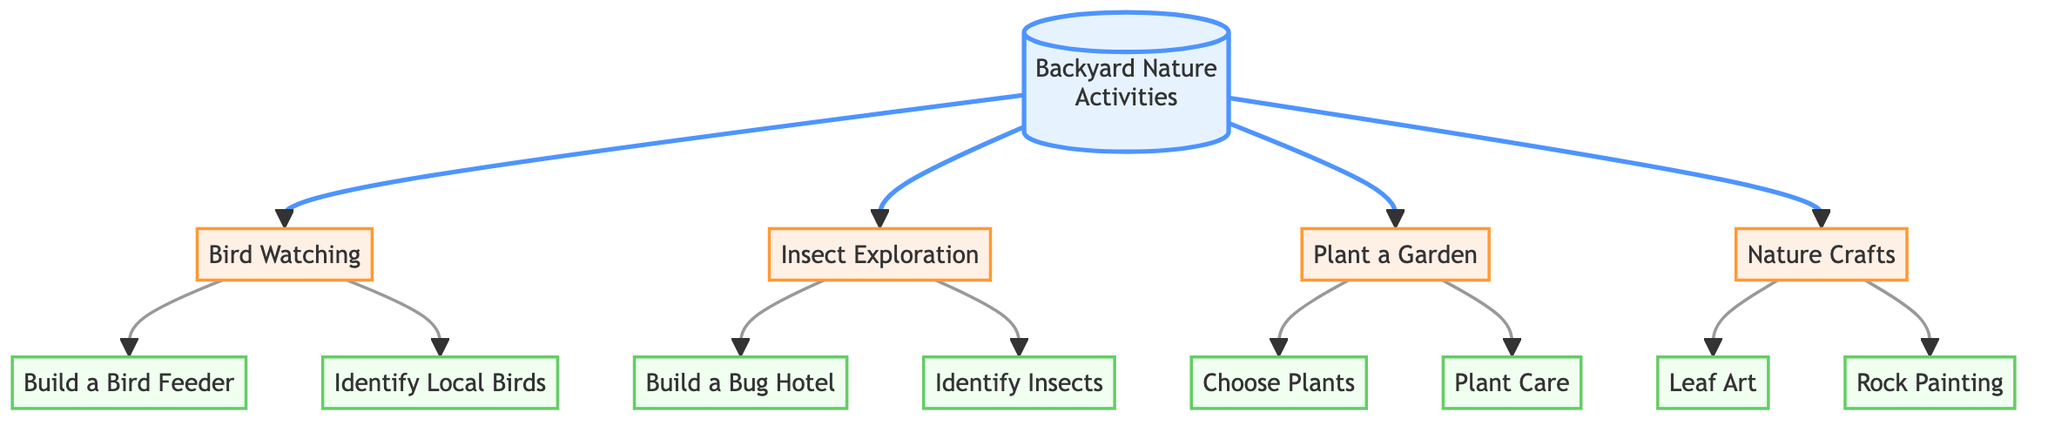What is the main topic of the diagram? The diagram starts with the node labeled "Backyard Nature Activities," indicating that this is the primary focus of the diagram.
Answer: Backyard Nature Activities How many main activities are listed in the diagram? The diagram shows three main activities branching from "Backyard Nature Activities": "Bird Watching," "Insect Exploration," and "Plant a Garden." Counting these gives us three activities.
Answer: 3 What is one subactivity under "Bird Watching"? One of the subactivities connected to "Bird Watching" is "Build a Bird Feeder," which directly links from the "Bird Watching" node.
Answer: Build a Bird Feeder Which main activity has the most subactivities associated with it? Examining the diagram, "Nature Crafts" has two subactivities: "Leaf Art" and "Rock Painting." In contrast, "Bird Watching" and "Insect Exploration" each have two subactivities, while "Plant a Garden" has two as well. However, they are equal, indicating that none has more than two.
Answer: Equal What are the subactivities connected to "Insect Exploration"? The diagram shows two subactivities connected to "Insect Exploration": "Build a Bug Hotel" and "Identify Insects." Both nodes directly branch from "Insect Exploration."
Answer: Build a Bug Hotel, Identify Insects How many edges are there in total in the diagram? By counting each directed connection (edge) present in the diagram, we find there are 12 edges connecting various nodes.
Answer: 12 What do "Choose Plants" and "Plant Care" have in common? Both "Choose Plants" and "Plant Care" are subactivities that branch from the main activity "Plant a Garden." They are directly connected to the same parent node.
Answer: They are subactivities of Plant a Garden Which activity is directly connected to the "Build a Bug Hotel"? The node "Build a Bug Hotel" is directly connected to the main activity "Insect Exploration," indicating it is a part of insect-related activities.
Answer: Insect Exploration How is "Leaf Art" related to "Backyard Nature Activities"? "Leaf Art" is a subactivity of "Nature Crafts," which in turn is a main activity branching out from "Backyard Nature Activities." Thus, there is a hierarchical relationship where "Leaf Art" is a part of "Backyard Nature Activities."
Answer: Nature Crafts 